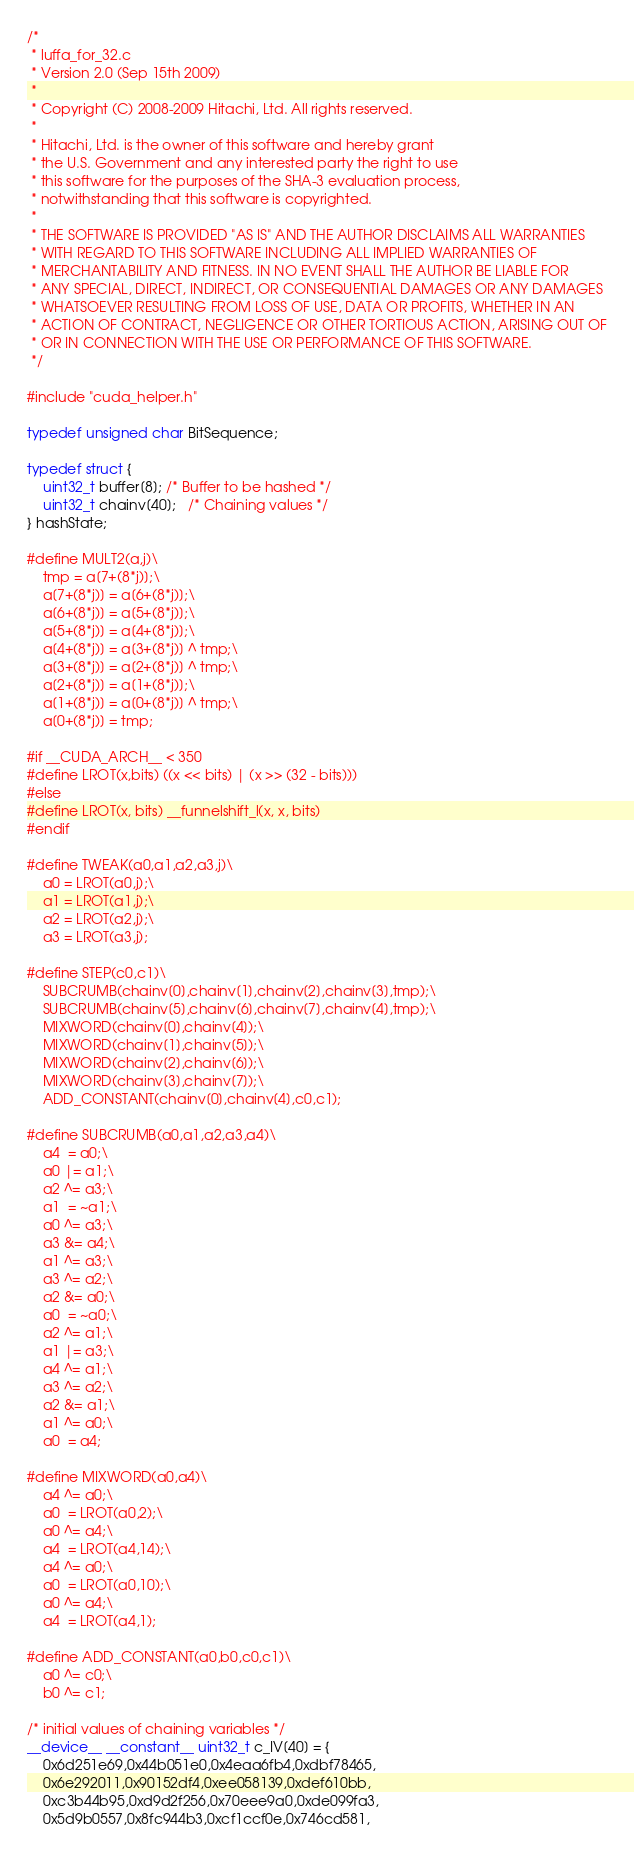Convert code to text. <code><loc_0><loc_0><loc_500><loc_500><_Cuda_>/*
 * luffa_for_32.c
 * Version 2.0 (Sep 15th 2009)
 *
 * Copyright (C) 2008-2009 Hitachi, Ltd. All rights reserved.
 *
 * Hitachi, Ltd. is the owner of this software and hereby grant
 * the U.S. Government and any interested party the right to use
 * this software for the purposes of the SHA-3 evaluation process,
 * notwithstanding that this software is copyrighted.
 *
 * THE SOFTWARE IS PROVIDED "AS IS" AND THE AUTHOR DISCLAIMS ALL WARRANTIES
 * WITH REGARD TO THIS SOFTWARE INCLUDING ALL IMPLIED WARRANTIES OF
 * MERCHANTABILITY AND FITNESS. IN NO EVENT SHALL THE AUTHOR BE LIABLE FOR
 * ANY SPECIAL, DIRECT, INDIRECT, OR CONSEQUENTIAL DAMAGES OR ANY DAMAGES
 * WHATSOEVER RESULTING FROM LOSS OF USE, DATA OR PROFITS, WHETHER IN AN
 * ACTION OF CONTRACT, NEGLIGENCE OR OTHER TORTIOUS ACTION, ARISING OUT OF
 * OR IN CONNECTION WITH THE USE OR PERFORMANCE OF THIS SOFTWARE.
 */

#include "cuda_helper.h"

typedef unsigned char BitSequence;

typedef struct {
    uint32_t buffer[8]; /* Buffer to be hashed */
    uint32_t chainv[40];   /* Chaining values */
} hashState;

#define MULT2(a,j)\
    tmp = a[7+(8*j)];\
    a[7+(8*j)] = a[6+(8*j)];\
    a[6+(8*j)] = a[5+(8*j)];\
    a[5+(8*j)] = a[4+(8*j)];\
    a[4+(8*j)] = a[3+(8*j)] ^ tmp;\
    a[3+(8*j)] = a[2+(8*j)] ^ tmp;\
    a[2+(8*j)] = a[1+(8*j)];\
    a[1+(8*j)] = a[0+(8*j)] ^ tmp;\
    a[0+(8*j)] = tmp;

#if __CUDA_ARCH__ < 350
#define LROT(x,bits) ((x << bits) | (x >> (32 - bits)))
#else
#define LROT(x, bits) __funnelshift_l(x, x, bits)
#endif

#define TWEAK(a0,a1,a2,a3,j)\
    a0 = LROT(a0,j);\
    a1 = LROT(a1,j);\
    a2 = LROT(a2,j);\
    a3 = LROT(a3,j);

#define STEP(c0,c1)\
    SUBCRUMB(chainv[0],chainv[1],chainv[2],chainv[3],tmp);\
    SUBCRUMB(chainv[5],chainv[6],chainv[7],chainv[4],tmp);\
    MIXWORD(chainv[0],chainv[4]);\
    MIXWORD(chainv[1],chainv[5]);\
    MIXWORD(chainv[2],chainv[6]);\
    MIXWORD(chainv[3],chainv[7]);\
    ADD_CONSTANT(chainv[0],chainv[4],c0,c1);

#define SUBCRUMB(a0,a1,a2,a3,a4)\
    a4  = a0;\
    a0 |= a1;\
    a2 ^= a3;\
    a1  = ~a1;\
    a0 ^= a3;\
    a3 &= a4;\
    a1 ^= a3;\
    a3 ^= a2;\
    a2 &= a0;\
    a0  = ~a0;\
    a2 ^= a1;\
    a1 |= a3;\
    a4 ^= a1;\
    a3 ^= a2;\
    a2 &= a1;\
    a1 ^= a0;\
    a0  = a4;

#define MIXWORD(a0,a4)\
    a4 ^= a0;\
    a0  = LROT(a0,2);\
    a0 ^= a4;\
    a4  = LROT(a4,14);\
    a4 ^= a0;\
    a0  = LROT(a0,10);\
    a0 ^= a4;\
    a4  = LROT(a4,1);

#define ADD_CONSTANT(a0,b0,c0,c1)\
    a0 ^= c0;\
    b0 ^= c1;

/* initial values of chaining variables */
__device__ __constant__ uint32_t c_IV[40] = {
    0x6d251e69,0x44b051e0,0x4eaa6fb4,0xdbf78465,
    0x6e292011,0x90152df4,0xee058139,0xdef610bb,
    0xc3b44b95,0xd9d2f256,0x70eee9a0,0xde099fa3,
    0x5d9b0557,0x8fc944b3,0xcf1ccf0e,0x746cd581,</code> 